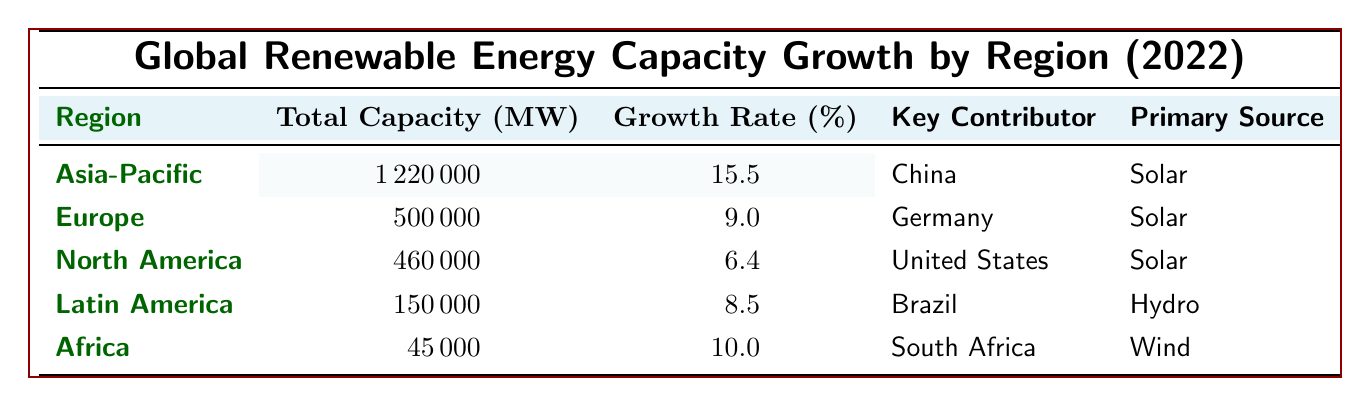What is the total renewable energy capacity in the Asia-Pacific region? The table shows that the total capacity for the Asia-Pacific region is listed as 1,220,000 MW.
Answer: 1,220,000 MW Which region has the highest growth rate in renewable energy capacity? According to the table, the Asia-Pacific region has the highest growth rate of 15.5%.
Answer: Asia-Pacific How much capacity was added by China in 2022? The table indicates that China added 600,000 MW of capacity in 2022.
Answer: 600,000 MW What is the average growth rate for all regions listed in the table? To find the average, we add the growth rates: (15.5 + 9.0 + 6.4 + 8.5 + 10.0) = 49.4%. There are 5 regions, so the average growth rate is 49.4 / 5 = 9.88%.
Answer: 9.88% Did any region have a growth rate below 7%? The North America region shows a growth rate of 6.4%, which is below 7%.
Answer: Yes Which region had the lowest total renewable energy capacity? The table shows that Africa has the lowest total capacity at 45,000 MW.
Answer: Africa How much capacity was added by the United States and Canada together? The table states that the United States added 30,000 MW and Canada added 12,000 MW. Adding these values together gives 30,000 + 12,000 = 42,000 MW.
Answer: 42,000 MW What percentage of the total capacity in Latin America was added by Brazil? In Latin America, the total capacity is 150,000 MW, and Brazil added 10,000 MW. The percentage is (10,000 / 150,000) * 100 = 6.67%.
Answer: 6.67% Which country's primary renewable energy source is hydro? The table indicates that Canada’s primary source is hydro.
Answer: Canada If we combine Africa and Latin America’s total capacities, how much do we get? The table shows Africa's capacity as 45,000 MW and Latin America's as 150,000 MW. Adding these gives 45,000 + 150,000 = 195,000 MW.
Answer: 195,000 MW 